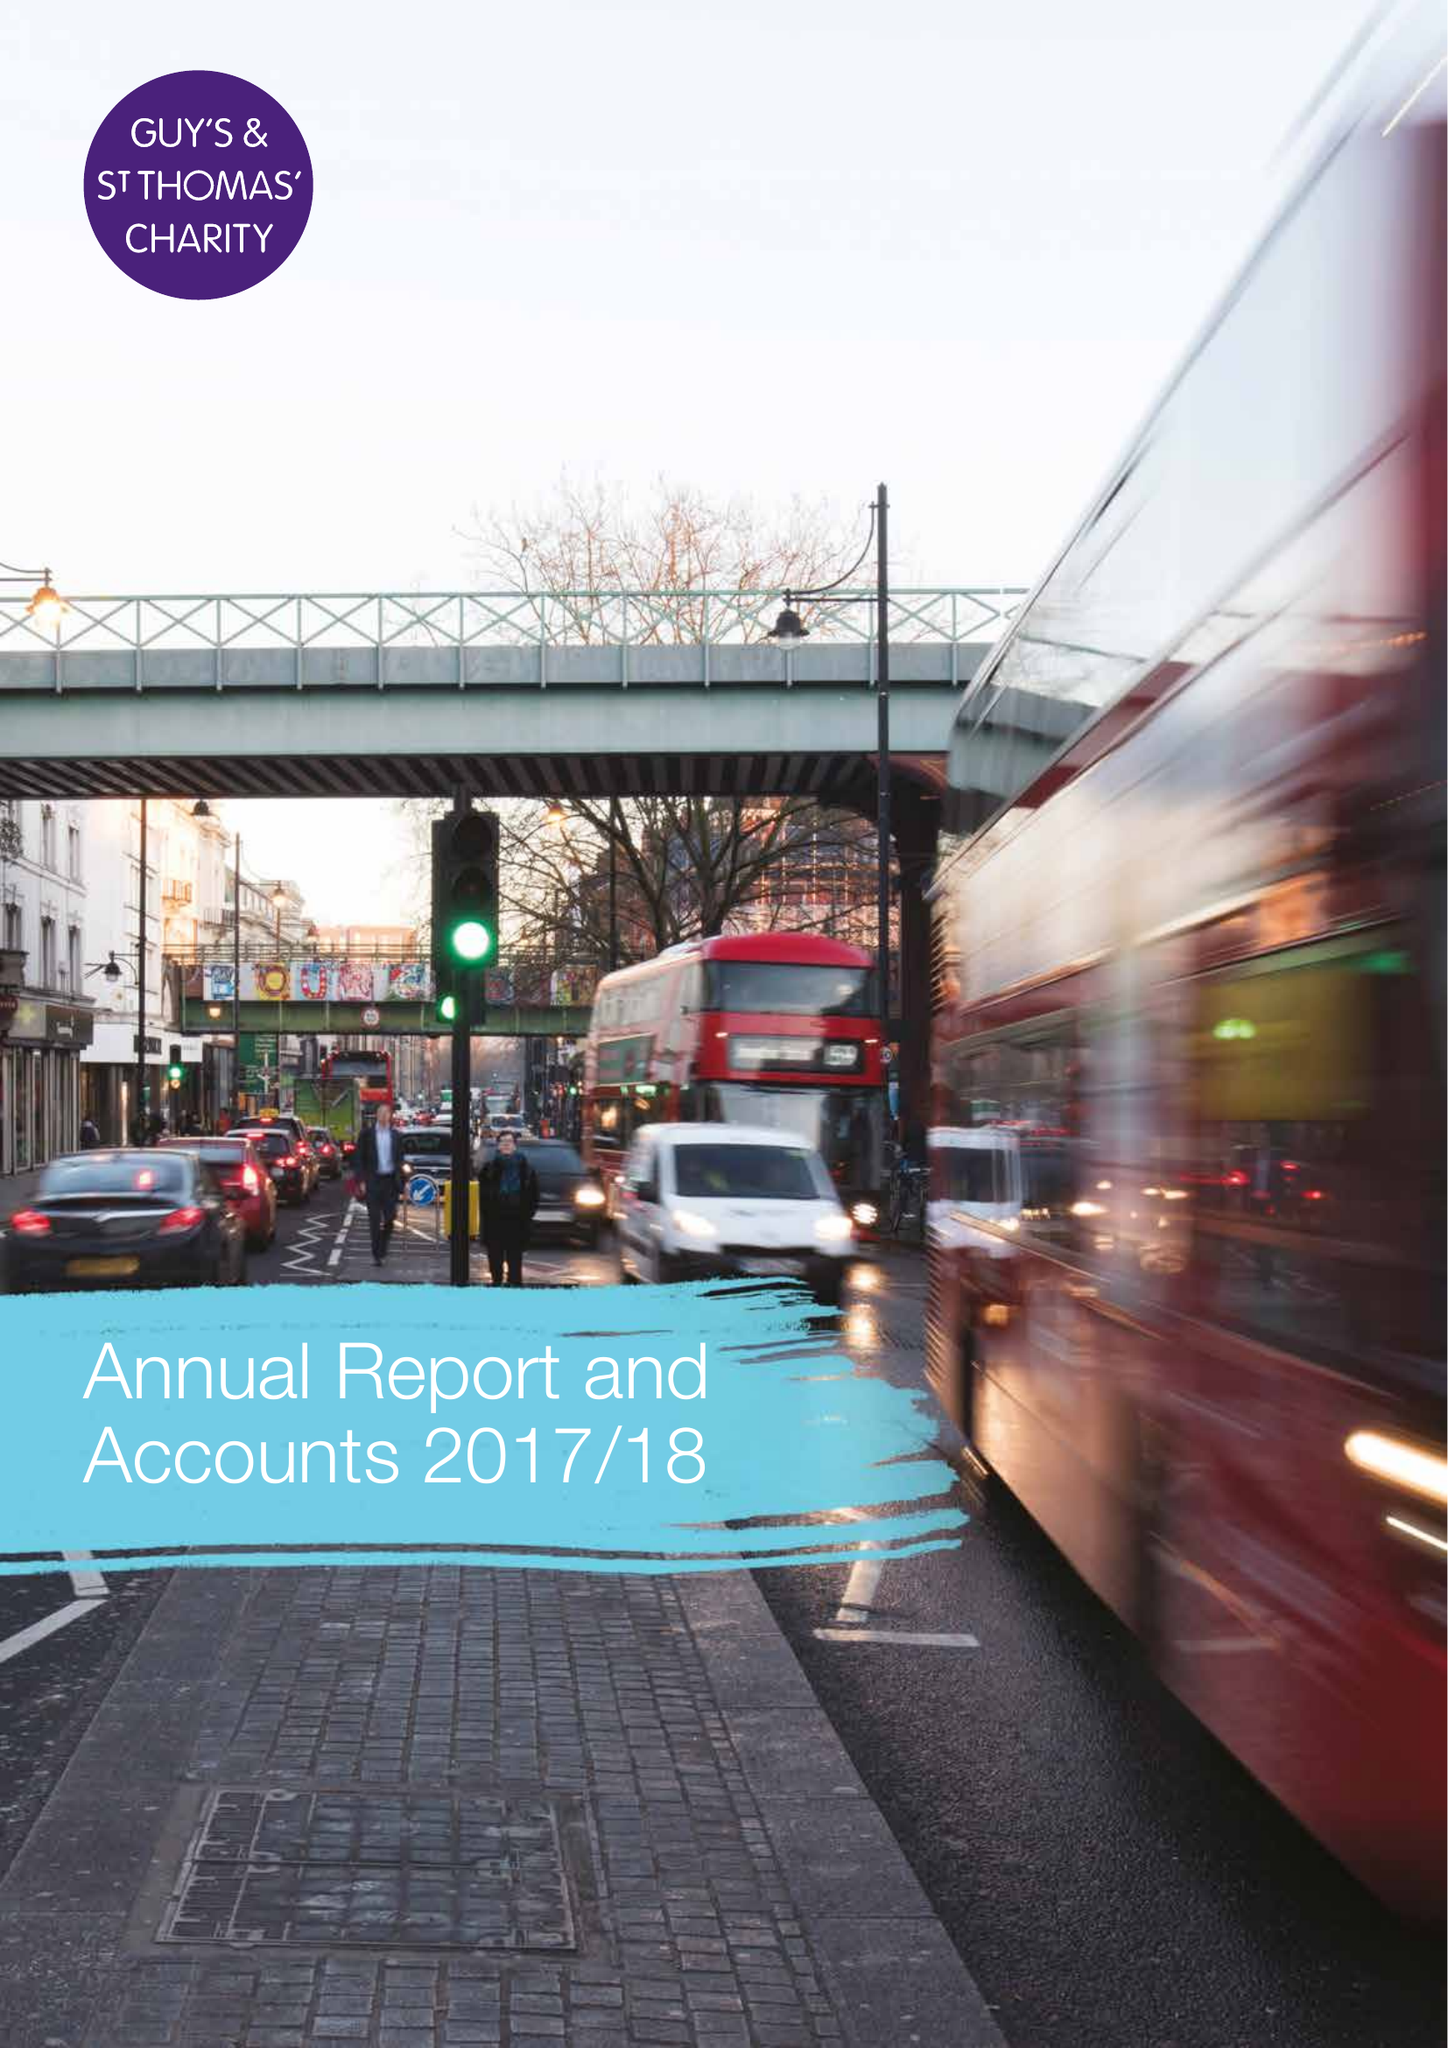What is the value for the report_date?
Answer the question using a single word or phrase. 2018-03-31 